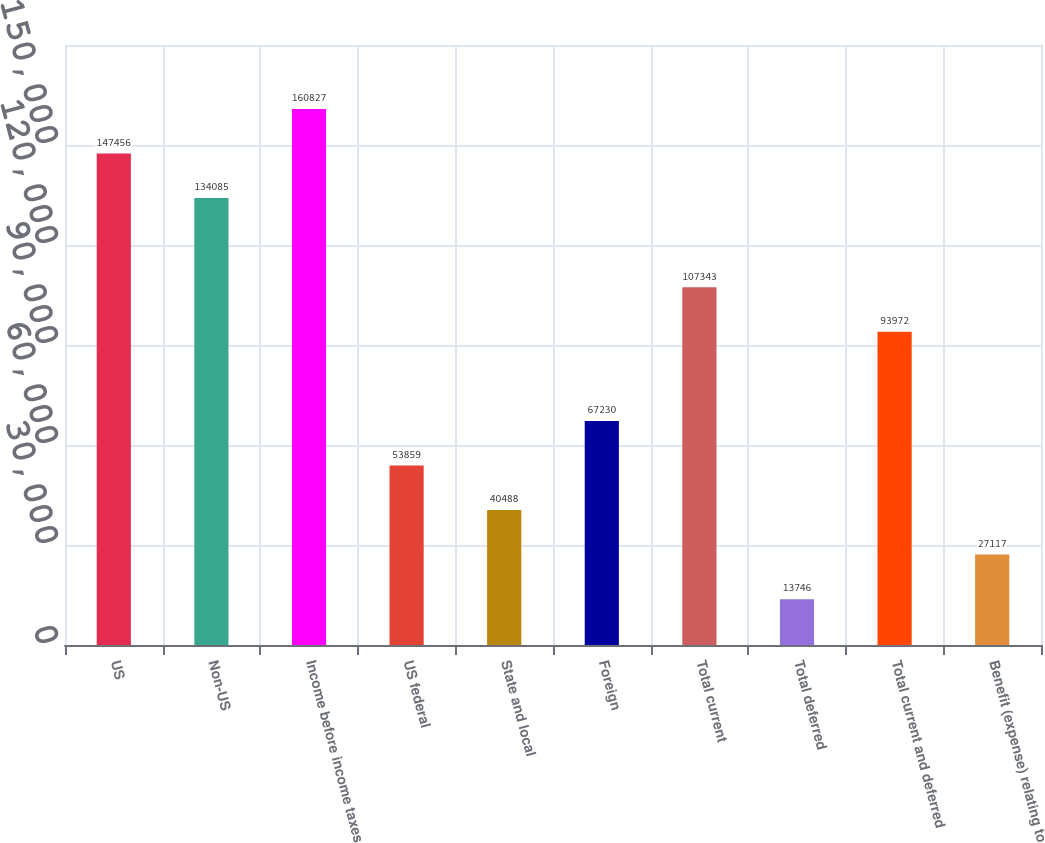Convert chart. <chart><loc_0><loc_0><loc_500><loc_500><bar_chart><fcel>US<fcel>Non-US<fcel>Income before income taxes<fcel>US federal<fcel>State and local<fcel>Foreign<fcel>Total current<fcel>Total deferred<fcel>Total current and deferred<fcel>Benefit (expense) relating to<nl><fcel>147456<fcel>134085<fcel>160827<fcel>53859<fcel>40488<fcel>67230<fcel>107343<fcel>13746<fcel>93972<fcel>27117<nl></chart> 